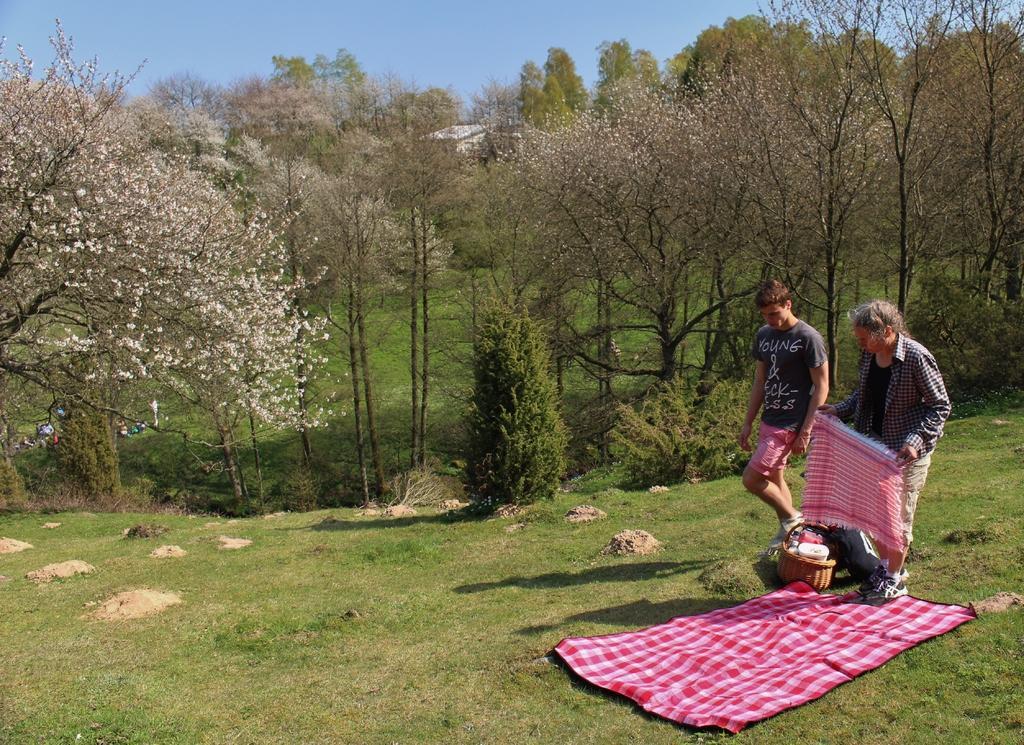Can you describe this image briefly? In this image we can see a man and woman, woman holding towel in her hands and there is a blanket on ground which is of pink color, we can see a basket in which there are some items and in the background of the image there are some trees, we can see a house, clear sky. 